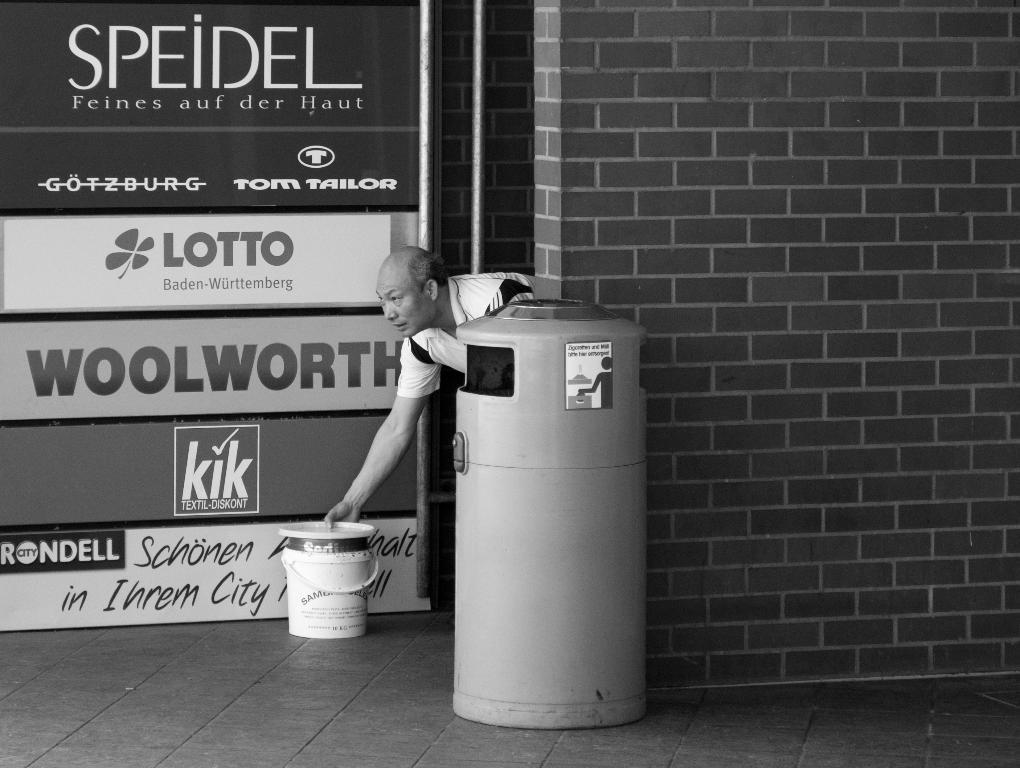What brand of watch is advertised?
Your answer should be very brief. Unanswerable. 